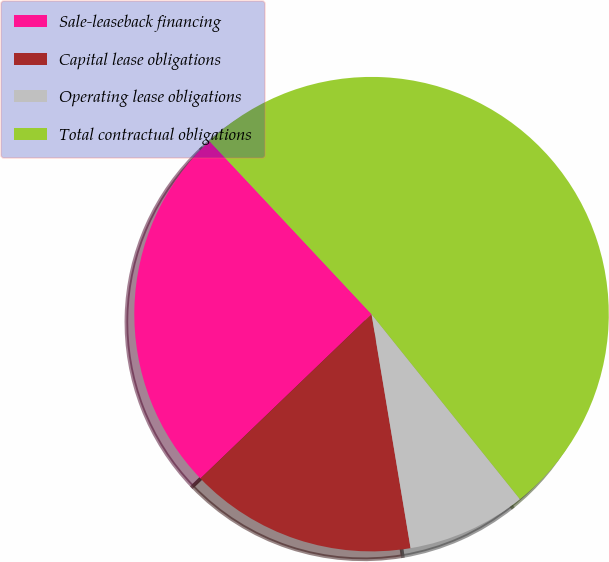<chart> <loc_0><loc_0><loc_500><loc_500><pie_chart><fcel>Sale-leaseback financing<fcel>Capital lease obligations<fcel>Operating lease obligations<fcel>Total contractual obligations<nl><fcel>25.2%<fcel>15.45%<fcel>8.13%<fcel>51.22%<nl></chart> 